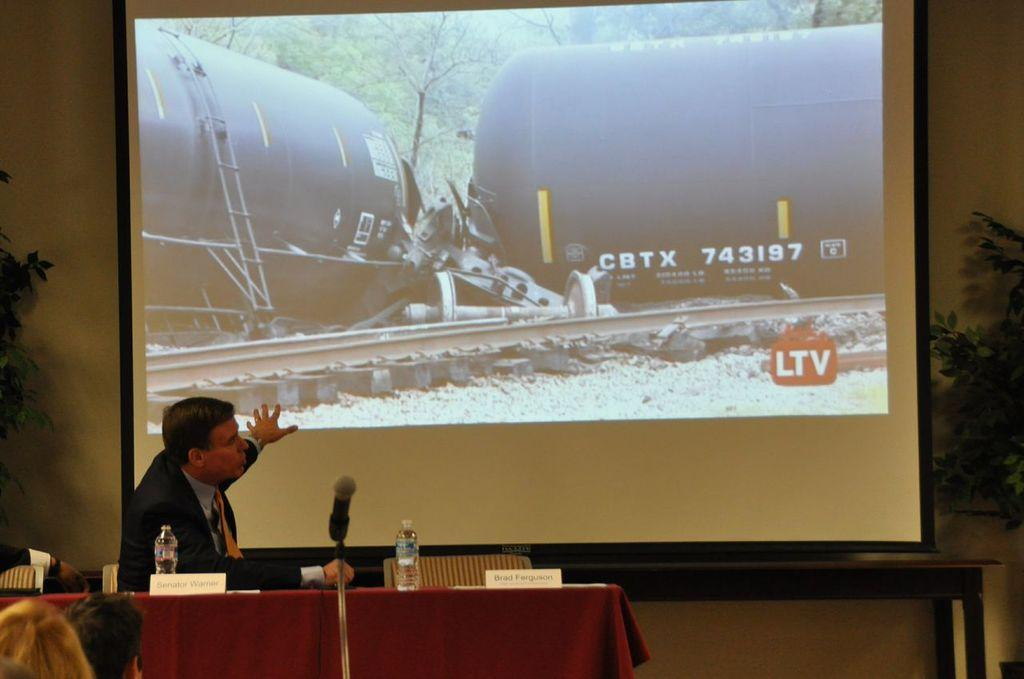Provide a one-sentence caption for the provided image. A man talks about a tanker labeled CBTX 743197. 